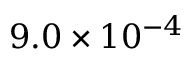<formula> <loc_0><loc_0><loc_500><loc_500>9 . 0 \times 1 0 ^ { - 4 }</formula> 